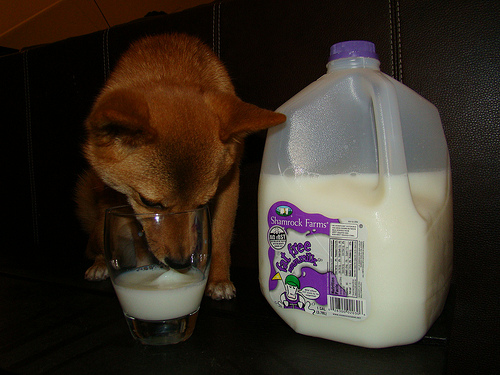<image>
Is the fur on the animal? Yes. Looking at the image, I can see the fur is positioned on top of the animal, with the animal providing support. Is the milk behind the dog? No. The milk is not behind the dog. From this viewpoint, the milk appears to be positioned elsewhere in the scene. Is the dog in the glass? No. The dog is not contained within the glass. These objects have a different spatial relationship. Where is the milk in relation to the dog? Is it next to the dog? Yes. The milk is positioned adjacent to the dog, located nearby in the same general area. 